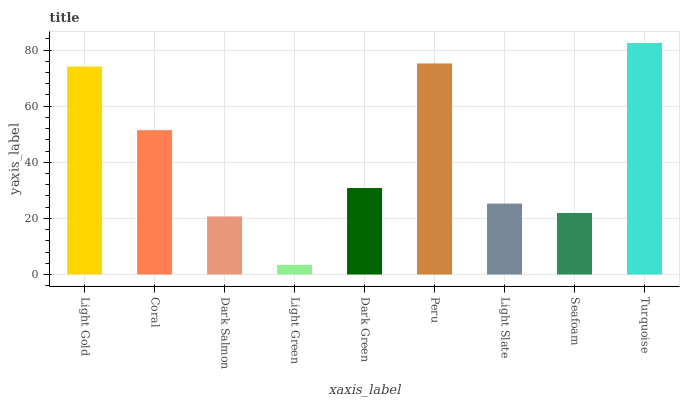Is Light Green the minimum?
Answer yes or no. Yes. Is Turquoise the maximum?
Answer yes or no. Yes. Is Coral the minimum?
Answer yes or no. No. Is Coral the maximum?
Answer yes or no. No. Is Light Gold greater than Coral?
Answer yes or no. Yes. Is Coral less than Light Gold?
Answer yes or no. Yes. Is Coral greater than Light Gold?
Answer yes or no. No. Is Light Gold less than Coral?
Answer yes or no. No. Is Dark Green the high median?
Answer yes or no. Yes. Is Dark Green the low median?
Answer yes or no. Yes. Is Peru the high median?
Answer yes or no. No. Is Light Gold the low median?
Answer yes or no. No. 